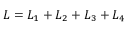Convert formula to latex. <formula><loc_0><loc_0><loc_500><loc_500>L = L _ { 1 } + L _ { 2 } + L _ { 3 } + L _ { 4 }</formula> 